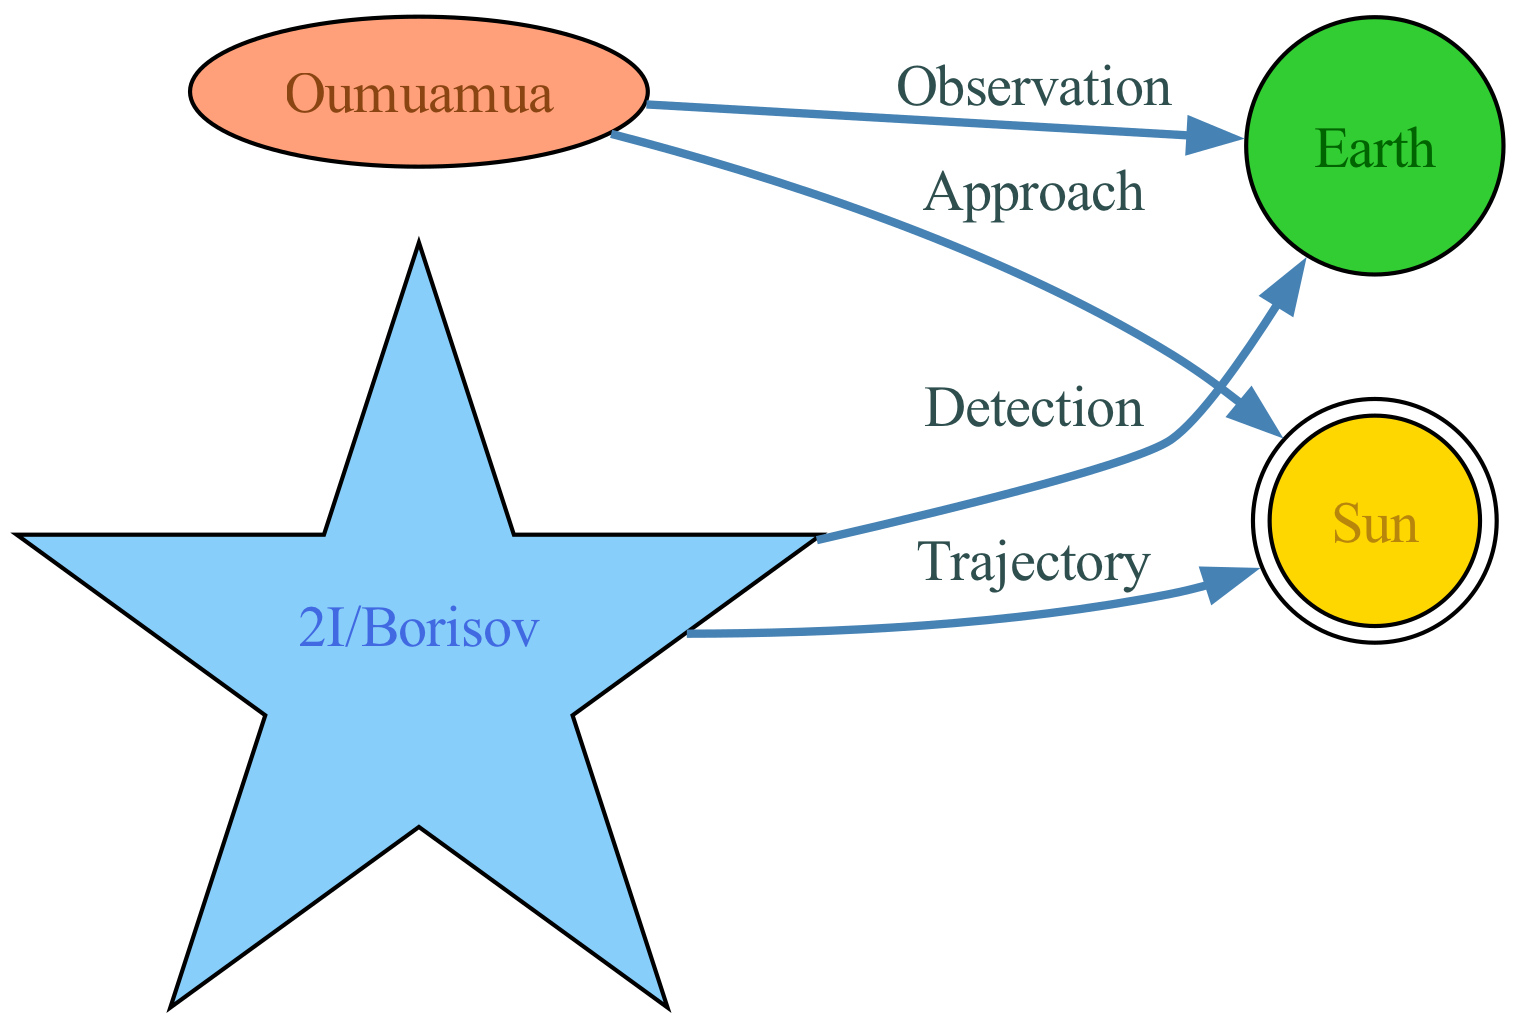What is the ID of the interstellar object named after Barack Obama? The diagram provides a list of nodes, and the one labeled 'Oumuamua' corresponds to "Interstellar Object named after Barack Obama." Its ID is clearly visible as "object1."
Answer: object1 How many nodes are displayed in the diagram? By counting the nodes in the diagram, I can see that there are four nodes: 'Oumuamua,' '2I/Borisov,' 'Earth,' and 'Sun.' Thus, the total is four nodes.
Answer: 4 What type is '2I/Borisov'? Looking at the description for '2I/Borisov,' it is specified as "Interstellar Comet named after Angela Merkel." Therefore, it is classified as a comet.
Answer: comet Which object has an "Observation" relationship with Earth? The relationship labeled "Observation" connects 'Oumuamua' to 'Earth.' Upon reviewing the edges, this is explicitly stated for that connection in the diagram.
Answer: 'Oumuamua' What is the trajectory of '2I/Borisov'? The edge labeled "Trajectory" indicates that 2I/Borisov's path "curves around the Sun." Therefore, this describes how it travels relative to the Sun.
Answer: curves around the Sun Which political figure is associated with the interstellar object named 'Oumuamua'? The description for 'Oumuamua' specifies it is named after Barack Obama. Therefore, the political figure associated with it is Barack Obama.
Answer: Barack Obama How many edges are displayed in the diagram? By examining the edges in the diagram, there are four edges represented, connecting the various objects and illustrating their relationships.
Answer: 4 What relationship connects '2I/Borisov' to Earth? The edge labeled "Detection" connects '2I/Borisov' to 'Earth,' indicating that it was detected by a telescope on Earth.
Answer: Detection Which node has a "Detection" relationship? The relationship labeled "Detection" directly corresponds to '2I/Borisov,' indicating that this comet was detected from Earth.
Answer: 2I/Borisov 